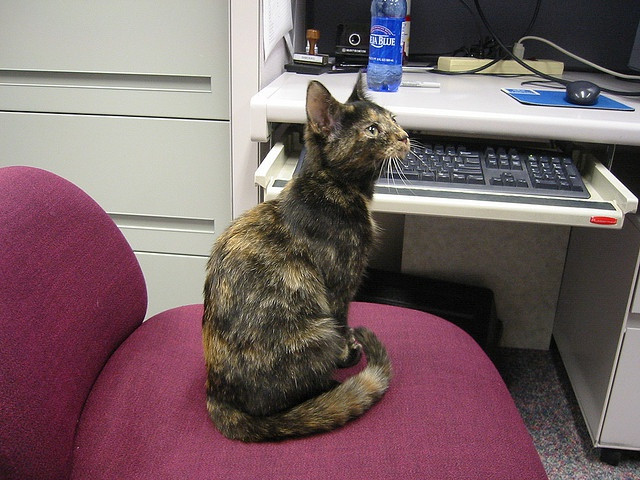Describe the objects in this image and their specific colors. I can see chair in darkgray, brown, maroon, and purple tones, cat in darkgray, black, and gray tones, keyboard in darkgray, gray, and black tones, bottle in darkgray, gray, blue, and darkblue tones, and mouse in darkgray, gray, and black tones in this image. 